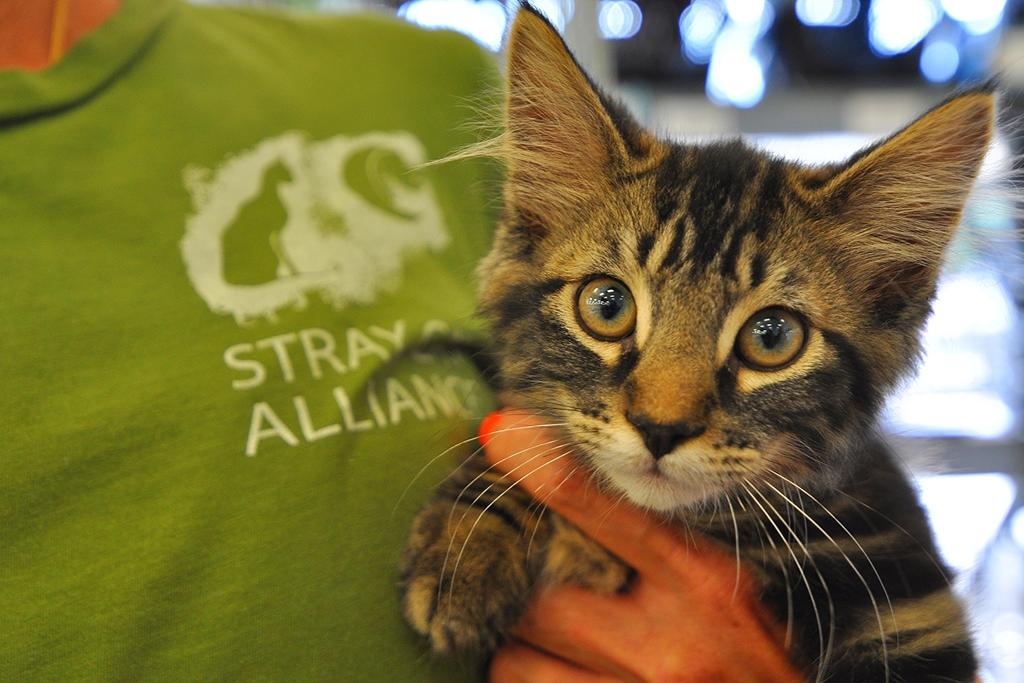What can be seen in the image? There is a person in the image. What is the person wearing? The person is wearing a green t-shirt. Are there any specific details on the t-shirt? Yes, there is writing and a logo on the t-shirt. What is the person holding in the image? The person is holding a cat. How would you describe the background of the image? The background of the image is blurred. What type of insect can be seen crawling on the person's arm in the image? There is no insect visible on the person's arm in the image. How does the person plan to wash the cat in the image? There is no indication in the image that the person is planning to wash the cat. 